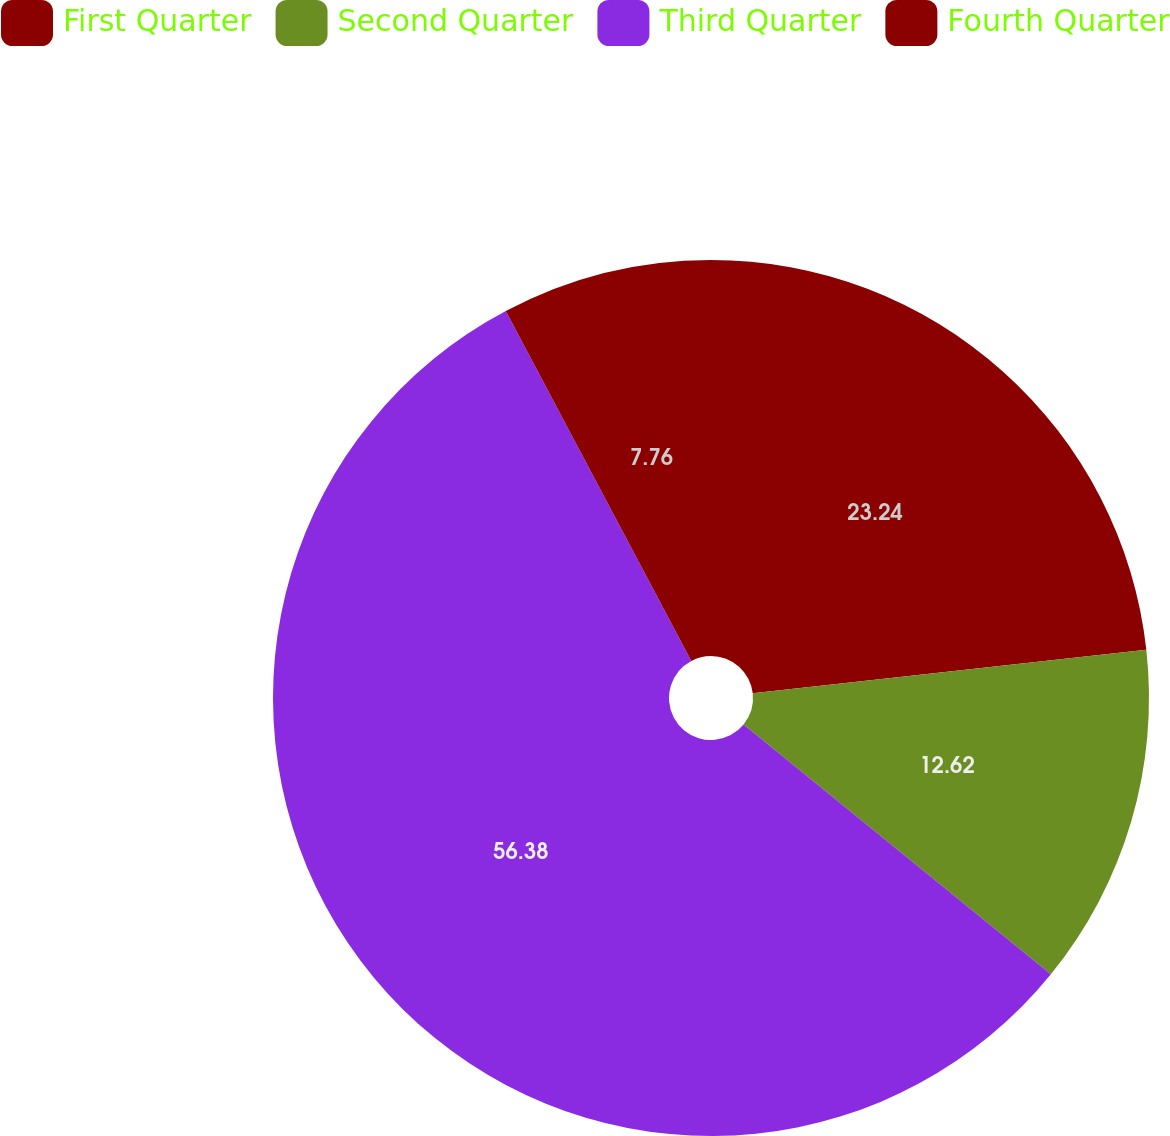<chart> <loc_0><loc_0><loc_500><loc_500><pie_chart><fcel>First Quarter<fcel>Second Quarter<fcel>Third Quarter<fcel>Fourth Quarter<nl><fcel>23.24%<fcel>12.62%<fcel>56.37%<fcel>7.76%<nl></chart> 